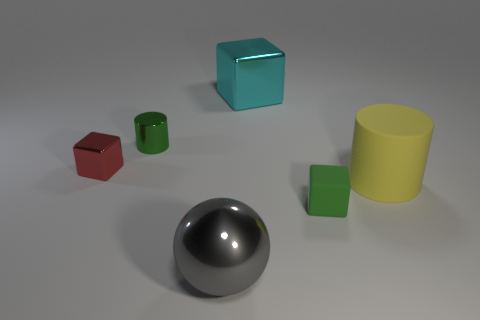Subtract all metallic cubes. How many cubes are left? 1 Subtract all purple balls. Subtract all blue cylinders. How many balls are left? 1 Subtract all gray spheres. How many green cylinders are left? 1 Add 2 red blocks. How many red blocks are left? 3 Add 4 big cyan metal cubes. How many big cyan metal cubes exist? 5 Add 3 large green objects. How many objects exist? 9 Subtract all cyan blocks. How many blocks are left? 2 Subtract 0 gray cubes. How many objects are left? 6 Subtract all cylinders. How many objects are left? 4 Subtract 1 spheres. How many spheres are left? 0 